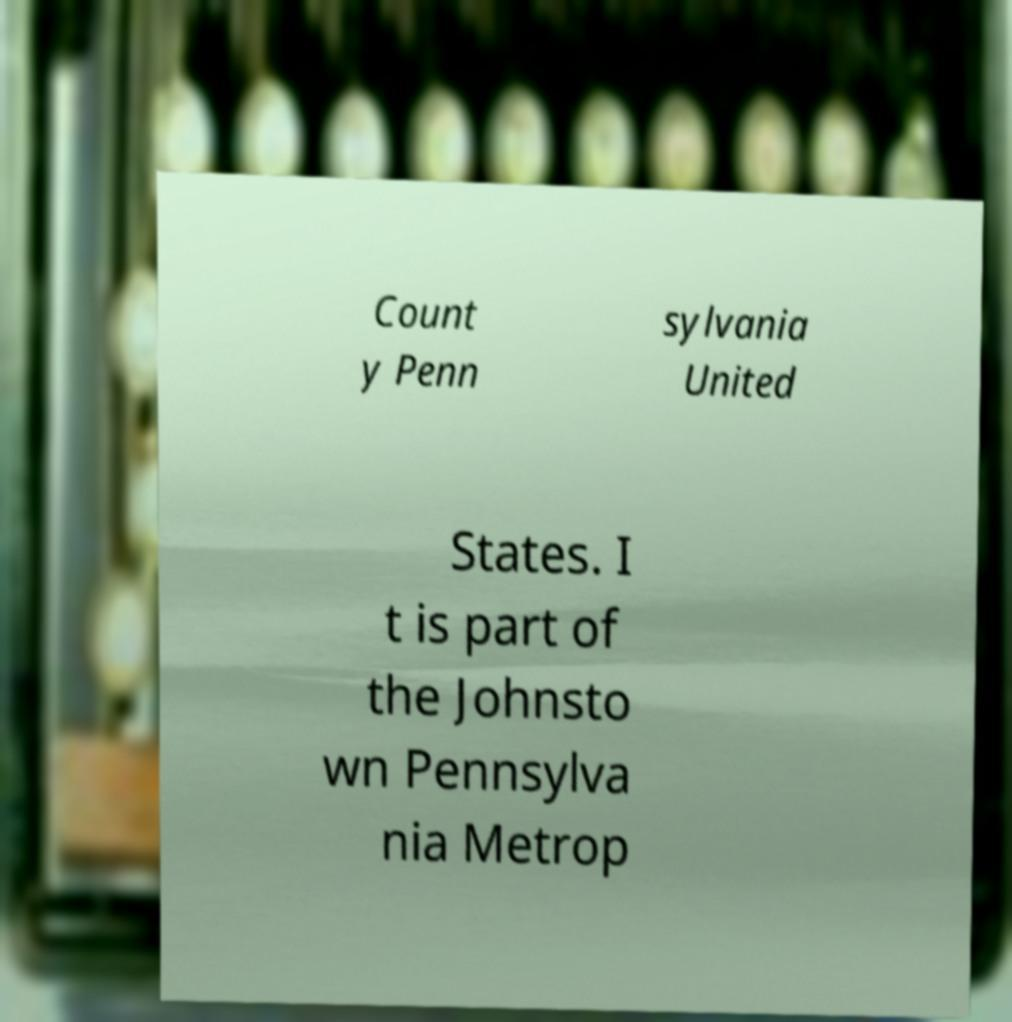Can you read and provide the text displayed in the image?This photo seems to have some interesting text. Can you extract and type it out for me? Count y Penn sylvania United States. I t is part of the Johnsto wn Pennsylva nia Metrop 